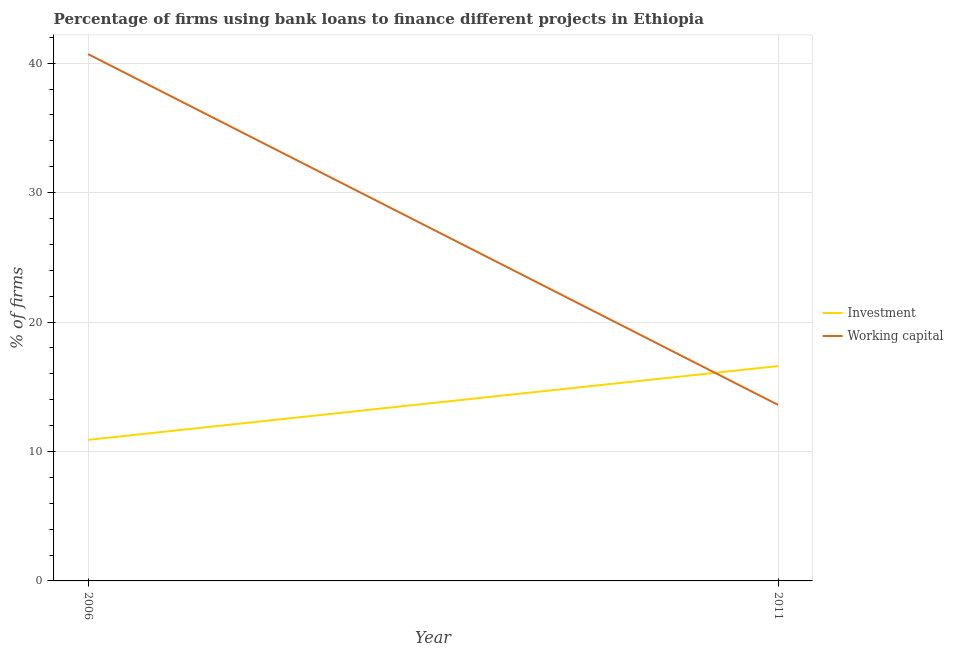Is the number of lines equal to the number of legend labels?
Ensure brevity in your answer.  Yes. What is the percentage of firms using banks to finance working capital in 2006?
Your answer should be compact. 40.7. Across all years, what is the maximum percentage of firms using banks to finance working capital?
Your answer should be very brief. 40.7. Across all years, what is the minimum percentage of firms using banks to finance investment?
Provide a succinct answer. 10.9. In which year was the percentage of firms using banks to finance investment maximum?
Your answer should be very brief. 2011. What is the total percentage of firms using banks to finance investment in the graph?
Ensure brevity in your answer.  27.5. What is the difference between the percentage of firms using banks to finance investment in 2006 and that in 2011?
Make the answer very short. -5.7. What is the difference between the percentage of firms using banks to finance working capital in 2011 and the percentage of firms using banks to finance investment in 2006?
Offer a very short reply. 2.7. What is the average percentage of firms using banks to finance investment per year?
Keep it short and to the point. 13.75. In the year 2006, what is the difference between the percentage of firms using banks to finance working capital and percentage of firms using banks to finance investment?
Provide a succinct answer. 29.8. In how many years, is the percentage of firms using banks to finance investment greater than 8 %?
Ensure brevity in your answer.  2. What is the ratio of the percentage of firms using banks to finance investment in 2006 to that in 2011?
Give a very brief answer. 0.66. Is the percentage of firms using banks to finance investment in 2006 less than that in 2011?
Ensure brevity in your answer.  Yes. Does the percentage of firms using banks to finance investment monotonically increase over the years?
Provide a short and direct response. Yes. Is the percentage of firms using banks to finance working capital strictly greater than the percentage of firms using banks to finance investment over the years?
Provide a short and direct response. No. Is the percentage of firms using banks to finance investment strictly less than the percentage of firms using banks to finance working capital over the years?
Your answer should be compact. No. How many lines are there?
Your response must be concise. 2. How many years are there in the graph?
Give a very brief answer. 2. What is the difference between two consecutive major ticks on the Y-axis?
Provide a short and direct response. 10. Are the values on the major ticks of Y-axis written in scientific E-notation?
Provide a succinct answer. No. How are the legend labels stacked?
Your answer should be compact. Vertical. What is the title of the graph?
Your answer should be compact. Percentage of firms using bank loans to finance different projects in Ethiopia. Does "Commercial service imports" appear as one of the legend labels in the graph?
Your response must be concise. No. What is the label or title of the X-axis?
Ensure brevity in your answer.  Year. What is the label or title of the Y-axis?
Make the answer very short. % of firms. What is the % of firms in Investment in 2006?
Provide a short and direct response. 10.9. What is the % of firms in Working capital in 2006?
Your response must be concise. 40.7. Across all years, what is the maximum % of firms in Investment?
Ensure brevity in your answer.  16.6. Across all years, what is the maximum % of firms of Working capital?
Offer a very short reply. 40.7. Across all years, what is the minimum % of firms in Working capital?
Your response must be concise. 13.6. What is the total % of firms in Investment in the graph?
Offer a very short reply. 27.5. What is the total % of firms in Working capital in the graph?
Give a very brief answer. 54.3. What is the difference between the % of firms in Working capital in 2006 and that in 2011?
Make the answer very short. 27.1. What is the difference between the % of firms of Investment in 2006 and the % of firms of Working capital in 2011?
Provide a succinct answer. -2.7. What is the average % of firms of Investment per year?
Keep it short and to the point. 13.75. What is the average % of firms in Working capital per year?
Offer a terse response. 27.15. In the year 2006, what is the difference between the % of firms of Investment and % of firms of Working capital?
Keep it short and to the point. -29.8. What is the ratio of the % of firms of Investment in 2006 to that in 2011?
Offer a terse response. 0.66. What is the ratio of the % of firms in Working capital in 2006 to that in 2011?
Offer a terse response. 2.99. What is the difference between the highest and the second highest % of firms in Investment?
Your answer should be very brief. 5.7. What is the difference between the highest and the second highest % of firms of Working capital?
Offer a terse response. 27.1. What is the difference between the highest and the lowest % of firms in Working capital?
Give a very brief answer. 27.1. 